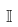Convert formula to latex. <formula><loc_0><loc_0><loc_500><loc_500>\mathbb { I }</formula> 